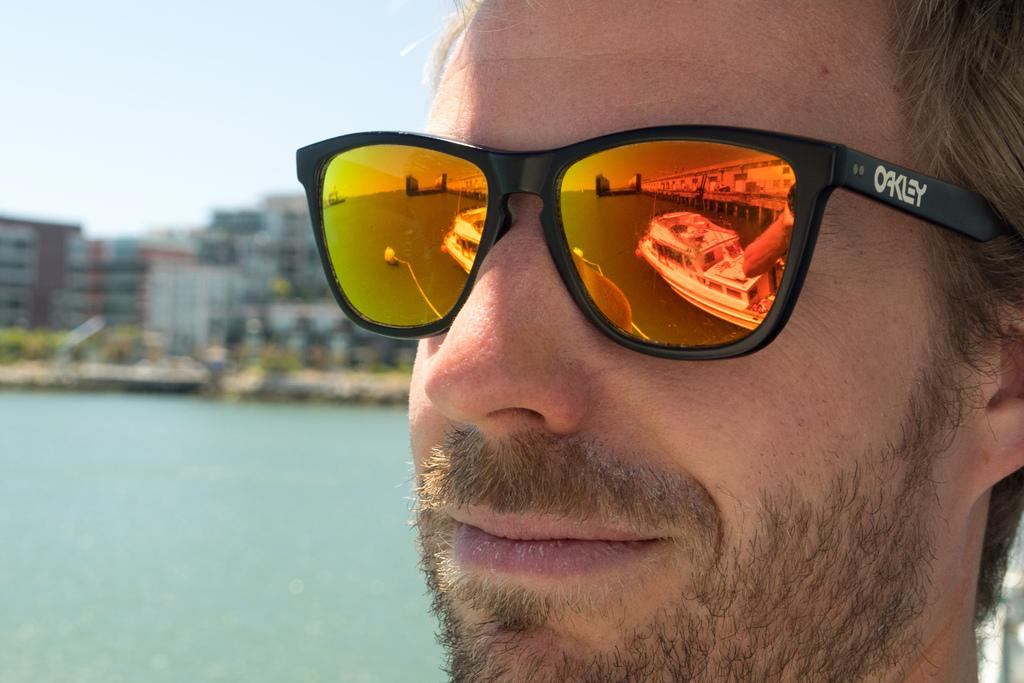Who or what is the main subject in the image? There is a person in the image. What is the person doing in the image? The person is facing the camera. Can you describe the person's appearance? The person is wearing shades. What can be seen in the background of the image? There are buildings, trees, water, and the sky visible in the background of the image. What is the color of the sky in the image? The sky is blue and white in color. What type of sock is the person wearing in the image? There is no sock visible in the image; the person is wearing shades. Can you tell me how many gates are present in the image? There are no gates present in the image; the background features buildings, trees, water, and the sky. 